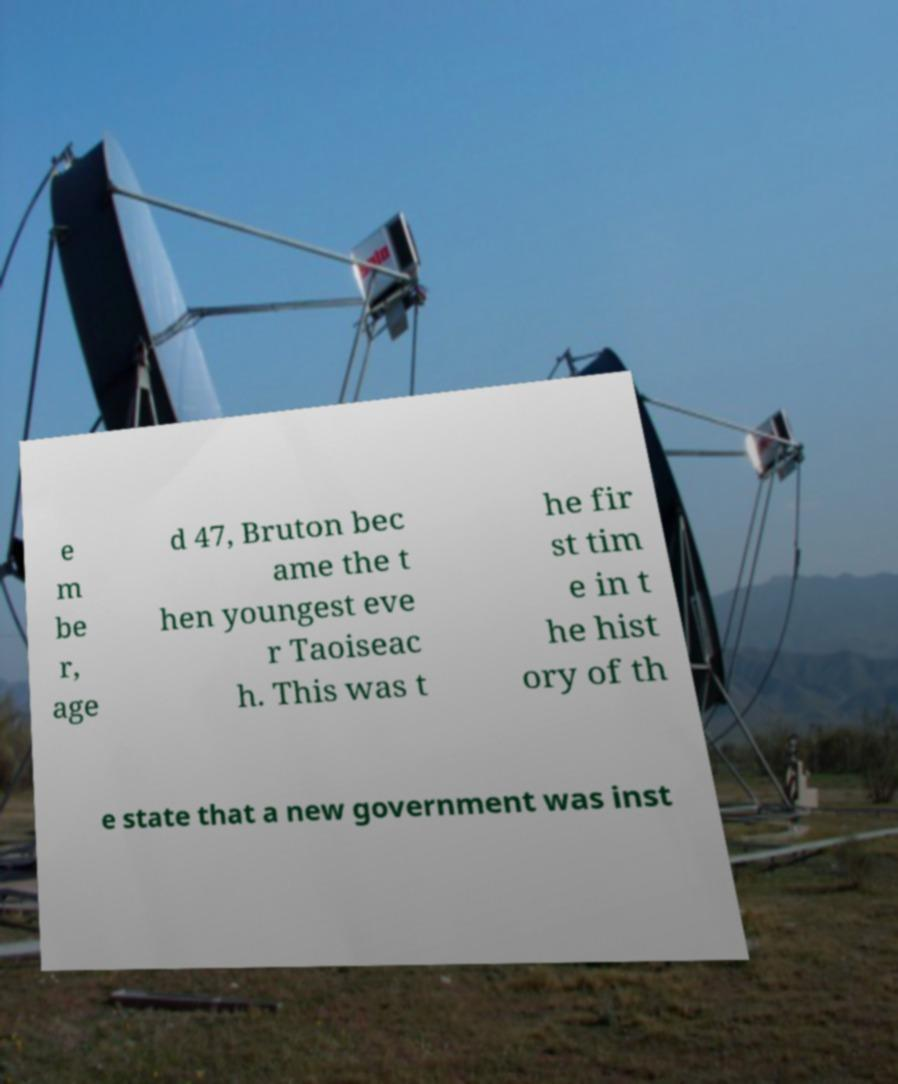For documentation purposes, I need the text within this image transcribed. Could you provide that? e m be r, age d 47, Bruton bec ame the t hen youngest eve r Taoiseac h. This was t he fir st tim e in t he hist ory of th e state that a new government was inst 